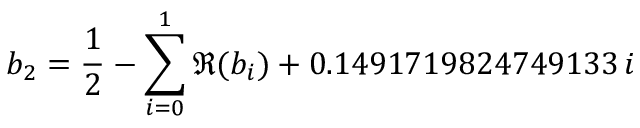<formula> <loc_0><loc_0><loc_500><loc_500>b _ { 2 } = \frac { 1 } { 2 } - \sum _ { i = 0 } ^ { 1 } \Re ( b _ { i } ) + 0 . 1 4 9 1 7 1 9 8 2 4 7 4 9 1 3 3 \, i</formula> 